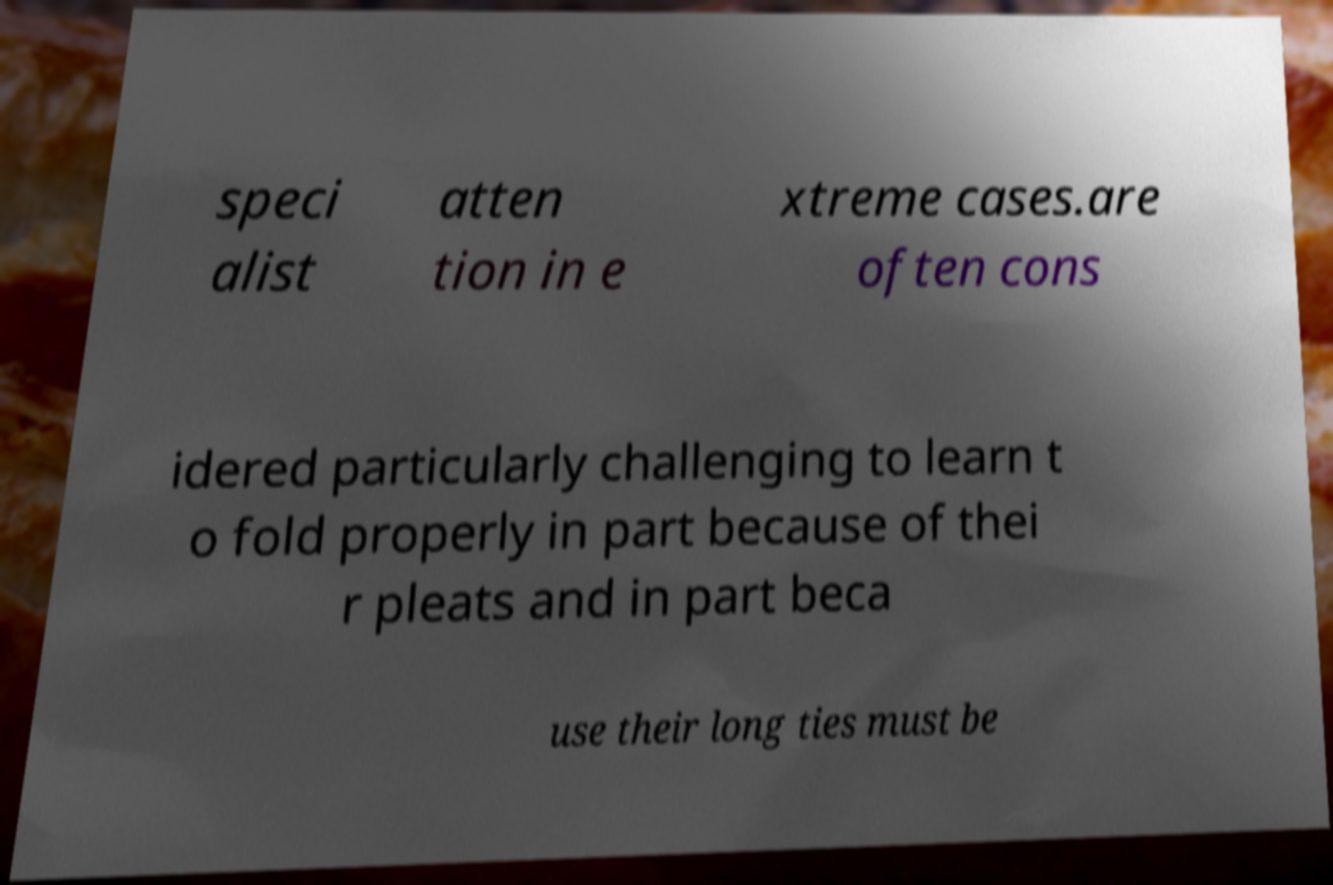Can you read and provide the text displayed in the image?This photo seems to have some interesting text. Can you extract and type it out for me? speci alist atten tion in e xtreme cases.are often cons idered particularly challenging to learn t o fold properly in part because of thei r pleats and in part beca use their long ties must be 